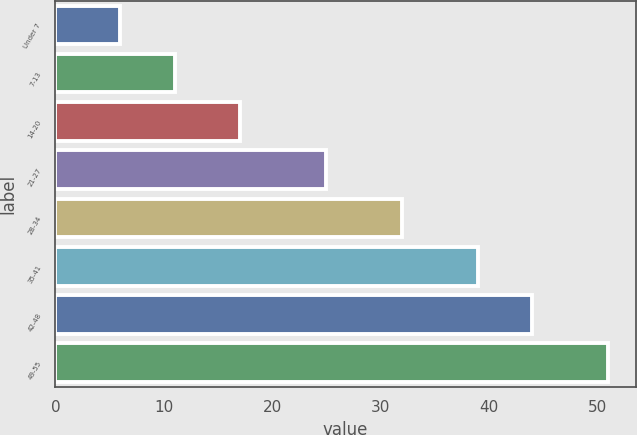Convert chart to OTSL. <chart><loc_0><loc_0><loc_500><loc_500><bar_chart><fcel>Under 7<fcel>7-13<fcel>14-20<fcel>21-27<fcel>28-34<fcel>35-41<fcel>42-48<fcel>49-55<nl><fcel>6<fcel>11<fcel>17<fcel>25<fcel>32<fcel>39<fcel>44<fcel>51<nl></chart> 